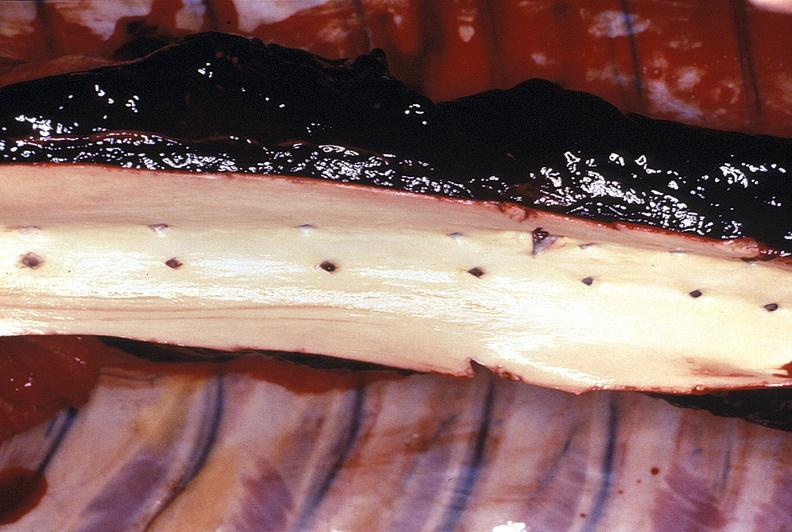s peritoneum present?
Answer the question using a single word or phrase. No 